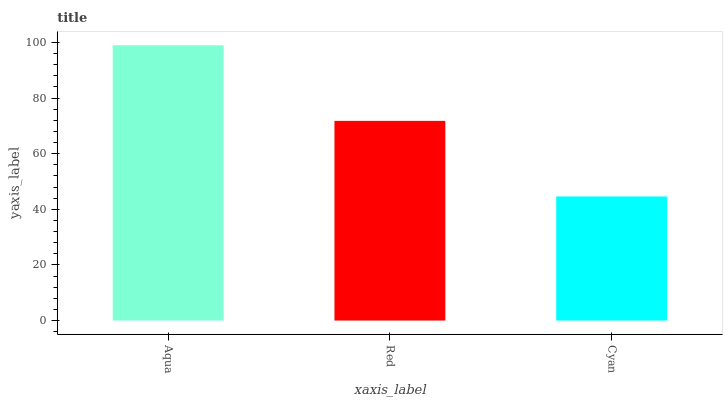Is Red the minimum?
Answer yes or no. No. Is Red the maximum?
Answer yes or no. No. Is Aqua greater than Red?
Answer yes or no. Yes. Is Red less than Aqua?
Answer yes or no. Yes. Is Red greater than Aqua?
Answer yes or no. No. Is Aqua less than Red?
Answer yes or no. No. Is Red the high median?
Answer yes or no. Yes. Is Red the low median?
Answer yes or no. Yes. Is Aqua the high median?
Answer yes or no. No. Is Aqua the low median?
Answer yes or no. No. 